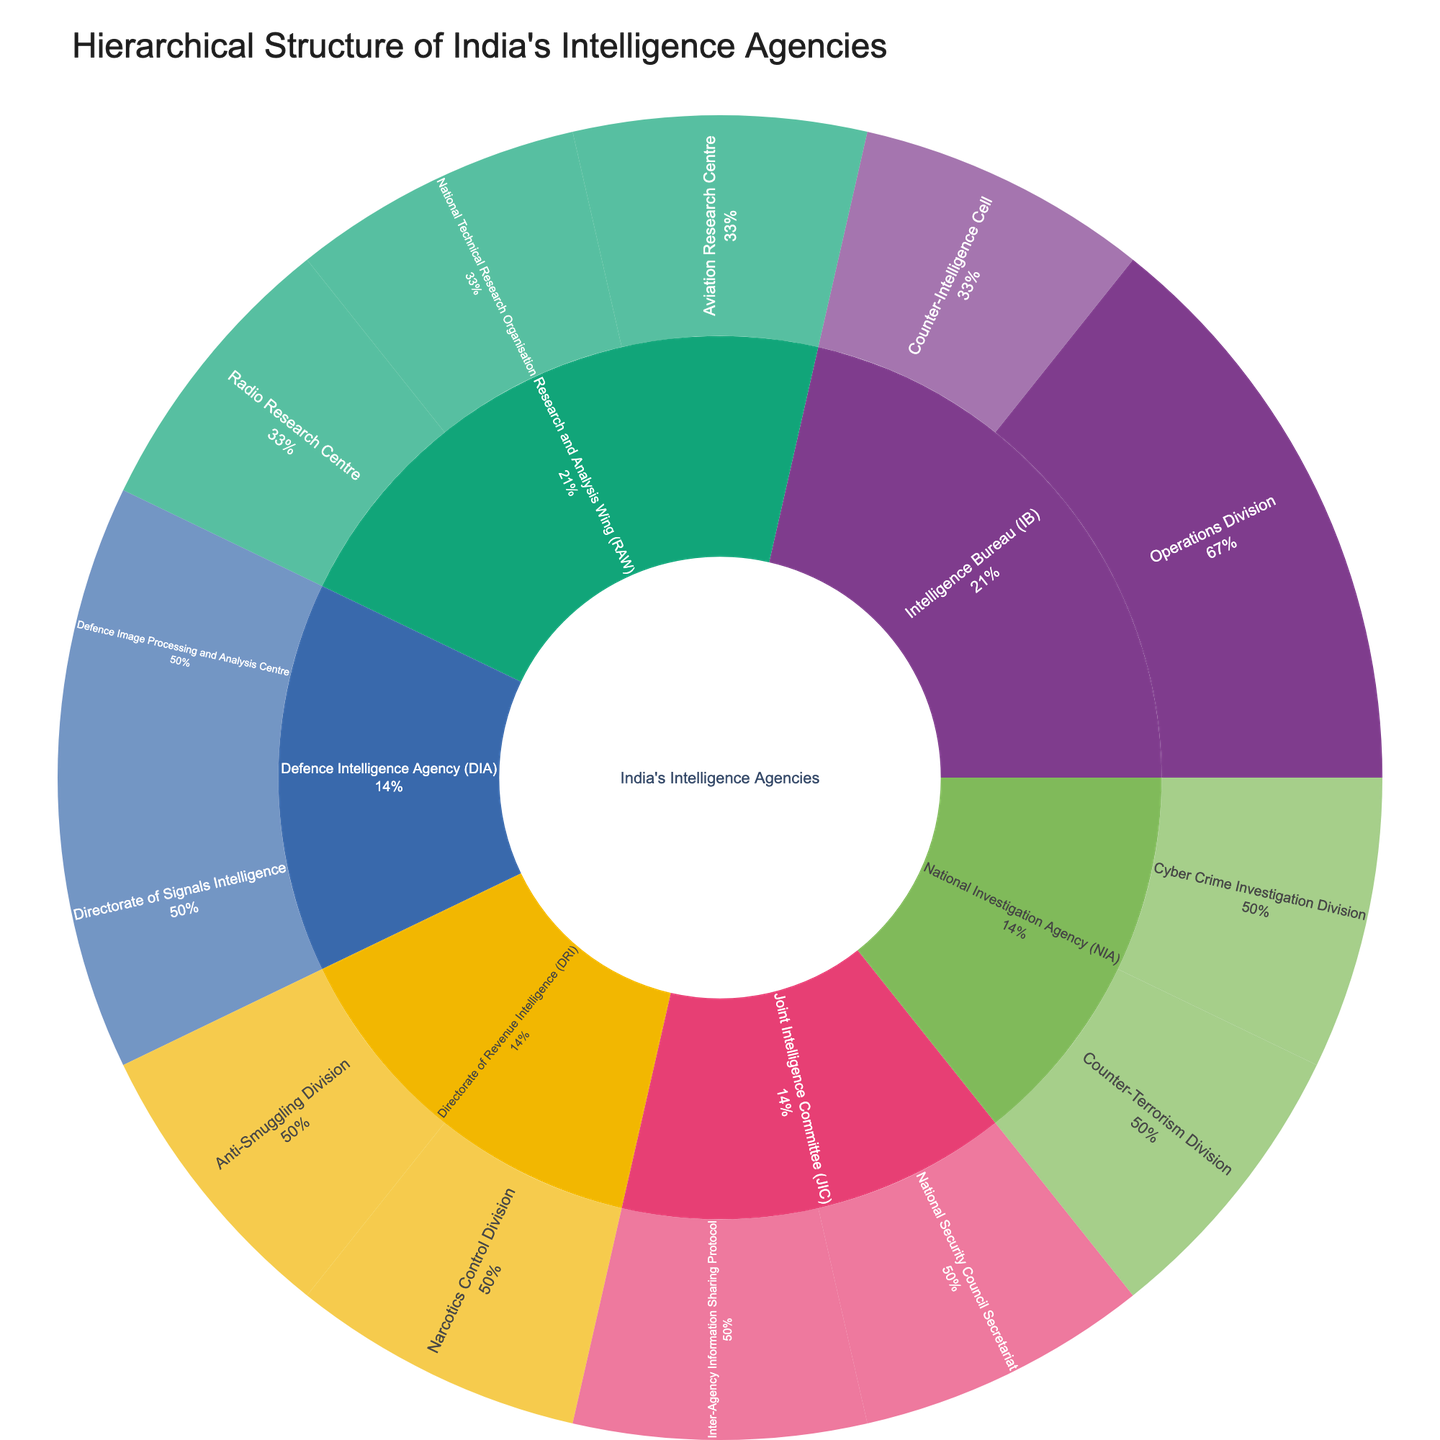What is the title of the sunburst plot? The title is usually displayed at the top of the plot and gives an overview of what the plot represents. In this case, it should help the viewer understand that the plot visualizes the structure of India’s intelligence agencies.
Answer: Hierarchical Structure of India's Intelligence Agencies Which agency has the most departments directly under it? To answer this, observe the number of segments radiating outward from the center for each main branch (RAW, IB, NIA, DIA, DRI, JIC) of the sunburst plot. Count the direct subdivisions under each agency.
Answer: Research and Analysis Wing (RAW) Which department under the Intelligence Bureau (IB) deals with Border Intelligence? First, locate the segment for Intelligence Bureau (IB), then look for its sub-segments. Find the sub-segment that indicates activities related to Border Intelligence.
Answer: Operations Division What is the proportion of the Joint Intelligence Committee (JIC) in terms of segments compared to other main agencies? Identify the segments corresponding to the JIC and compare their relative size with segments representing other main agencies like RAW, IB, NIA, and DIA. Each main segment’s size dictates the relative proportion.
Answer: JIC has fewer segments compared to other main agencies like RAW, IB, NIA, DIA, which indicates fewer subdivisions proportionally How many divisions are directly part of the National Investigation Agency (NIA)? Point out the NIA’s segment and count the number of direct subdivisions radiating from it.
Answer: Two Which agency includes the Narcotics Control Division? Identify each segment under different main branches, specifically look for the "Narcotics Control Division". See which main agency it branches out from.
Answer: Directorate of Revenue Intelligence (DRI) Explain the hierarchical relationship between the Defence Intelligence Agency (DIA) and the Defence Image Processing and Analysis Centre. Observe the sunburst plot’s structure: locate the DIA and track its sub-segments to find the Defence Image Processing and Analysis Centre.
Answer: The Defence Image Processing and Analysis Centre is a sub-division under the Defence Intelligence Agency (DIA) What are the main sectors under Research and Analysis Wing (RAW)? Identify the primary branches radiating from RAW’s main segment in the plot. These sectors will be the immediate subdivisions under RAW.
Answer: Aviation Research Centre, National Technical Research Organisation, Radio Research Centre Compare the number of segments present for RAW and DIA. Which one has more subdivisions? Count the subdivisions (segments) for RAW and DIA, then compare the counts to determine which has more.
Answer: RAW has more subdivisions Which agency has the Counter-Terrorism Division? Locate the segment labeled "Counter-Terrorism Division" and trace it back to its main agency segment to identify which agency it belongs to.
Answer: National Investigation Agency (NIA) 